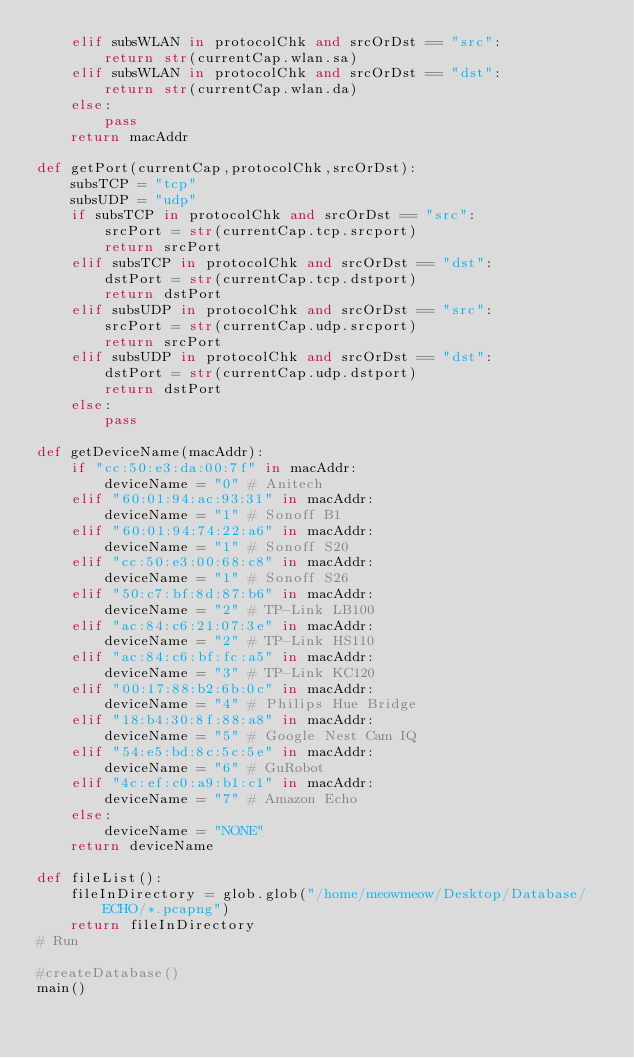<code> <loc_0><loc_0><loc_500><loc_500><_Python_>    elif subsWLAN in protocolChk and srcOrDst == "src":
        return str(currentCap.wlan.sa)
    elif subsWLAN in protocolChk and srcOrDst == "dst":
        return str(currentCap.wlan.da)
    else:
        pass
    return macAddr

def getPort(currentCap,protocolChk,srcOrDst):
    subsTCP = "tcp"
    subsUDP = "udp"
    if subsTCP in protocolChk and srcOrDst == "src":
        srcPort = str(currentCap.tcp.srcport)
        return srcPort
    elif subsTCP in protocolChk and srcOrDst == "dst":
        dstPort = str(currentCap.tcp.dstport)
        return dstPort
    elif subsUDP in protocolChk and srcOrDst == "src":
        srcPort = str(currentCap.udp.srcport)
        return srcPort
    elif subsUDP in protocolChk and srcOrDst == "dst":
        dstPort = str(currentCap.udp.dstport)
        return dstPort
    else:
        pass

def getDeviceName(macAddr):
    if "cc:50:e3:da:00:7f" in macAddr:
        deviceName = "0" # Anitech
    elif "60:01:94:ac:93:31" in macAddr:
        deviceName = "1" # Sonoff B1
    elif "60:01:94:74:22:a6" in macAddr:
        deviceName = "1" # Sonoff S20
    elif "cc:50:e3:00:68:c8" in macAddr:
        deviceName = "1" # Sonoff S26
    elif "50:c7:bf:8d:87:b6" in macAddr:
        deviceName = "2" # TP-Link LB100
    elif "ac:84:c6:21:07:3e" in macAddr:
        deviceName = "2" # TP-Link HS110
    elif "ac:84:c6:bf:fc:a5" in macAddr:
        deviceName = "3" # TP-Link KC120
    elif "00:17:88:b2:6b:0c" in macAddr:
        deviceName = "4" # Philips Hue Bridge
    elif "18:b4:30:8f:88:a8" in macAddr:
        deviceName = "5" # Google Nest Cam IQ
    elif "54:e5:bd:8c:5c:5e" in macAddr:
        deviceName = "6" # GuRobot
    elif "4c:ef:c0:a9:b1:c1" in macAddr:
        deviceName = "7" # Amazon Echo
    else:
        deviceName = "NONE"
    return deviceName

def fileList():
    fileInDirectory = glob.glob("/home/meowmeow/Desktop/Database/ECHO/*.pcapng")
    return fileInDirectory
# Run

#createDatabase()
main()
</code> 